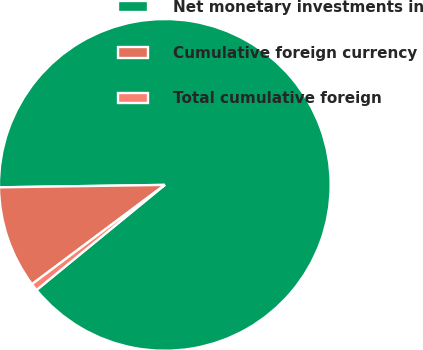<chart> <loc_0><loc_0><loc_500><loc_500><pie_chart><fcel>Net monetary investments in<fcel>Cumulative foreign currency<fcel>Total cumulative foreign<nl><fcel>89.32%<fcel>9.98%<fcel>0.71%<nl></chart> 